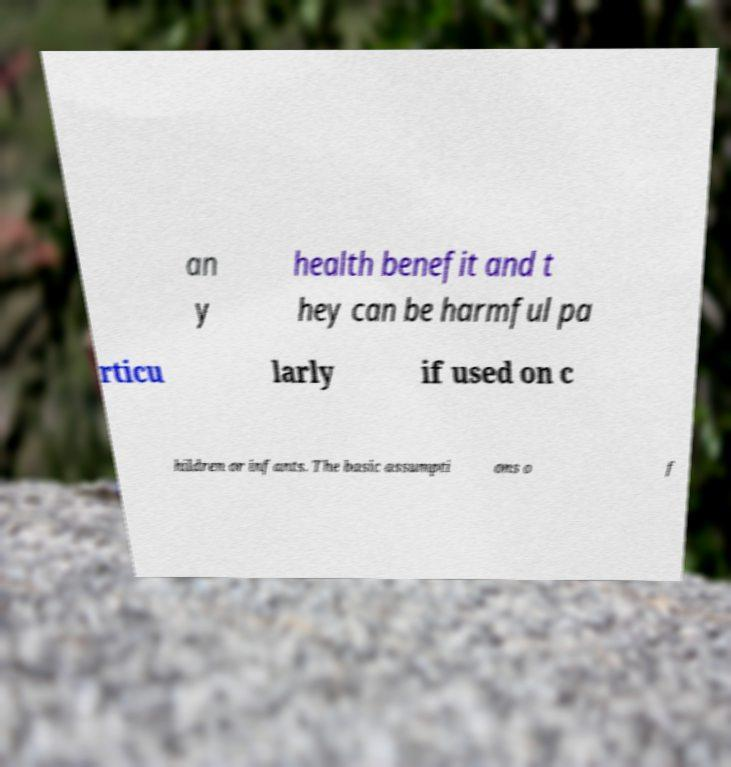Can you accurately transcribe the text from the provided image for me? an y health benefit and t hey can be harmful pa rticu larly if used on c hildren or infants. The basic assumpti ons o f 